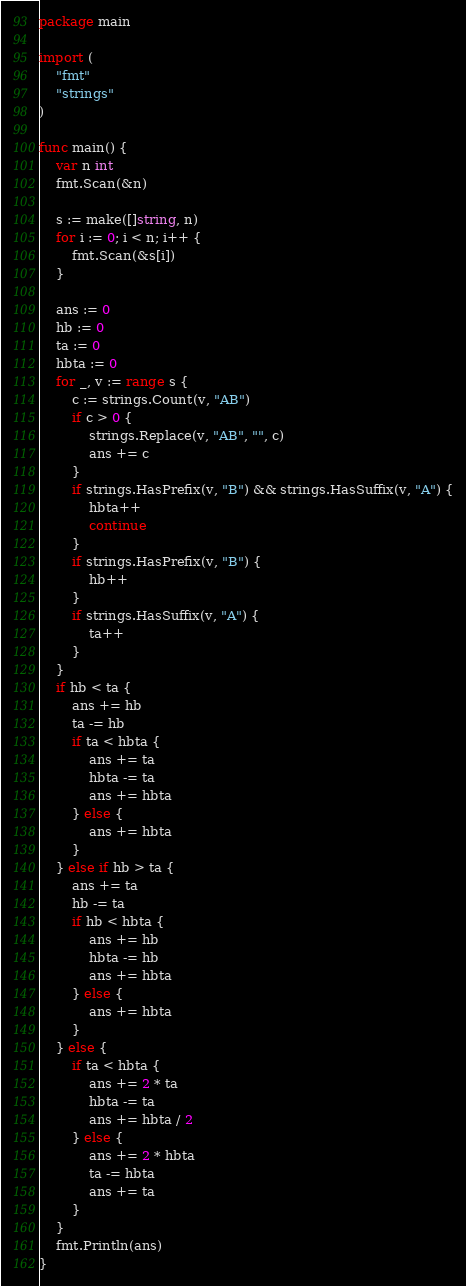Convert code to text. <code><loc_0><loc_0><loc_500><loc_500><_Go_>package main

import (
	"fmt"
	"strings"
)

func main() {
	var n int
	fmt.Scan(&n)

	s := make([]string, n)
	for i := 0; i < n; i++ {
		fmt.Scan(&s[i])
	}

	ans := 0
	hb := 0
	ta := 0
	hbta := 0
	for _, v := range s {
		c := strings.Count(v, "AB")
		if c > 0 {
			strings.Replace(v, "AB", "", c)
			ans += c
		}
		if strings.HasPrefix(v, "B") && strings.HasSuffix(v, "A") {
			hbta++
			continue
		}
		if strings.HasPrefix(v, "B") {
			hb++
		}
		if strings.HasSuffix(v, "A") {
			ta++
		}
	}
	if hb < ta {
		ans += hb
		ta -= hb
		if ta < hbta {
			ans += ta
			hbta -= ta
			ans += hbta
		} else {
			ans += hbta
		}
	} else if hb > ta {
		ans += ta
		hb -= ta
		if hb < hbta {
			ans += hb
			hbta -= hb
			ans += hbta
		} else {
			ans += hbta
		}
	} else {
		if ta < hbta {
			ans += 2 * ta
			hbta -= ta
			ans += hbta / 2
		} else {
			ans += 2 * hbta
			ta -= hbta
			ans += ta
		}
	}
	fmt.Println(ans)
}
</code> 